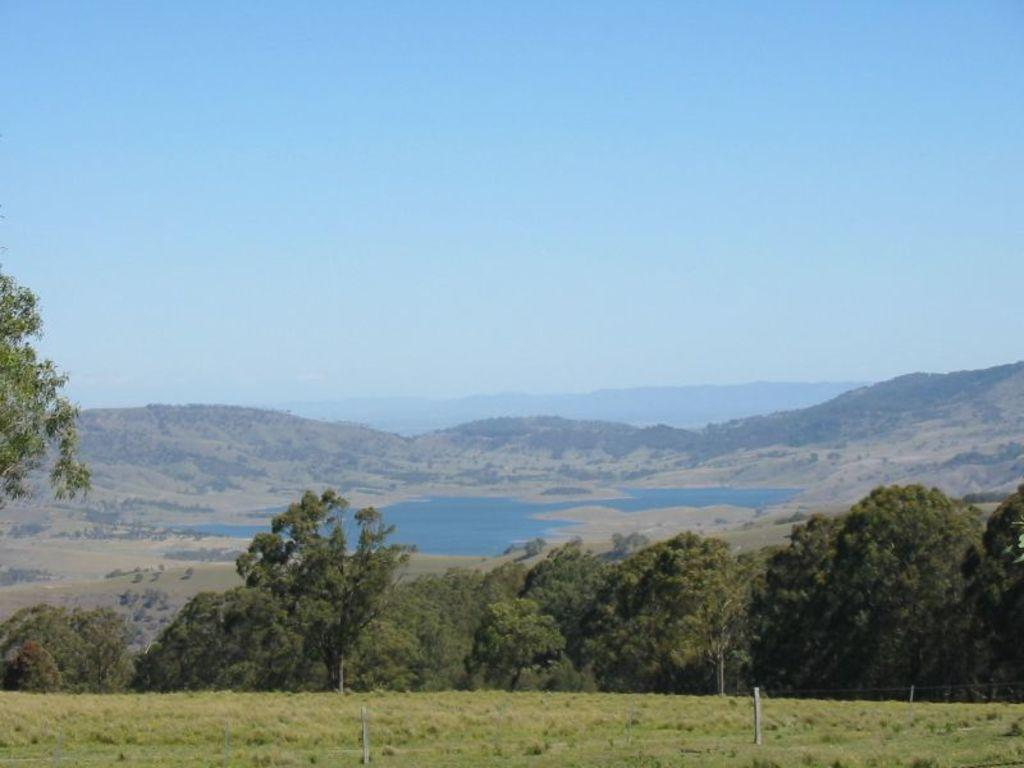What type of vegetation can be seen in the image? There are trees in the image. What is the ground covered with in the image? There is grass visible in the image. What geographical features are present in the image? There are hills in the image. What natural element is visible in the image? There is water visible in the image. What can be seen above the landscape in the image? The sky is visible in the image. What type of brush is used to paint the bridge in the image? There is no bridge present in the image, and therefore no brush or painting activity can be observed. 